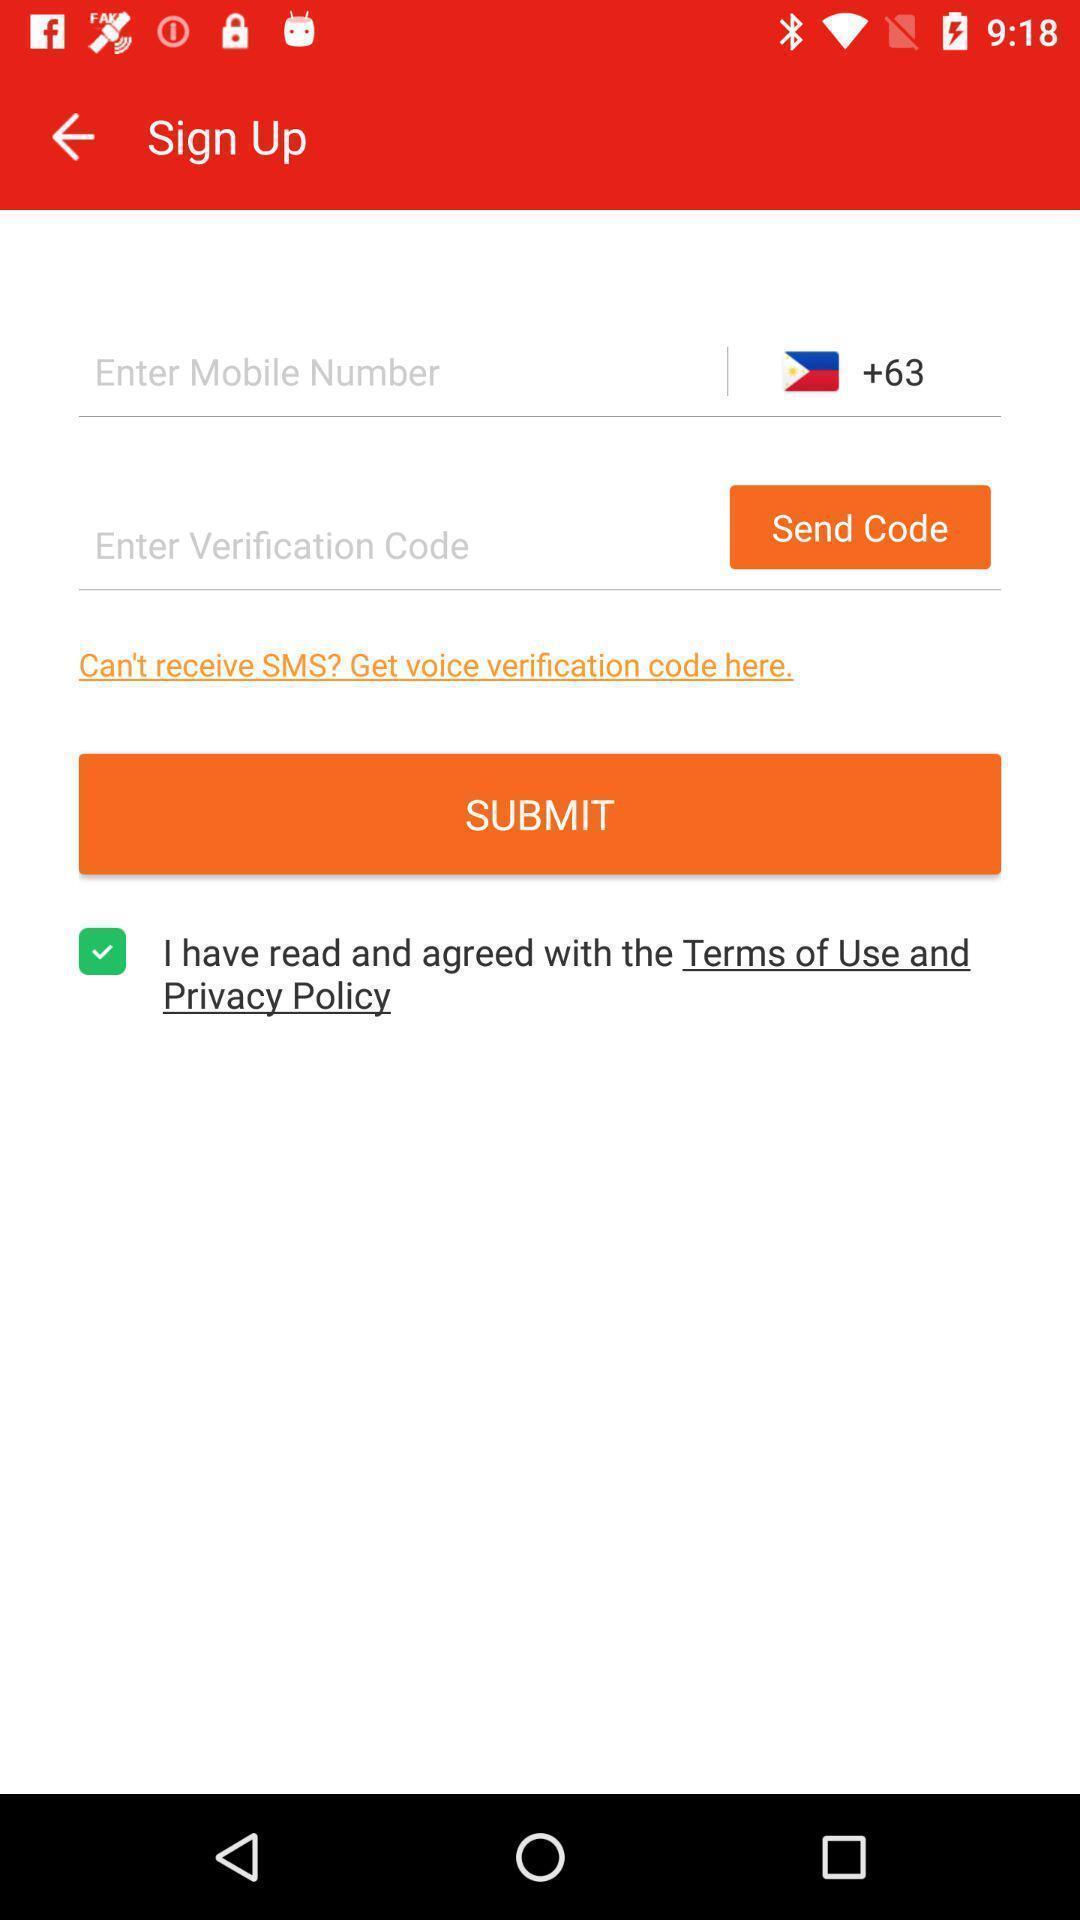Give me a summary of this screen capture. Sign-up page. 